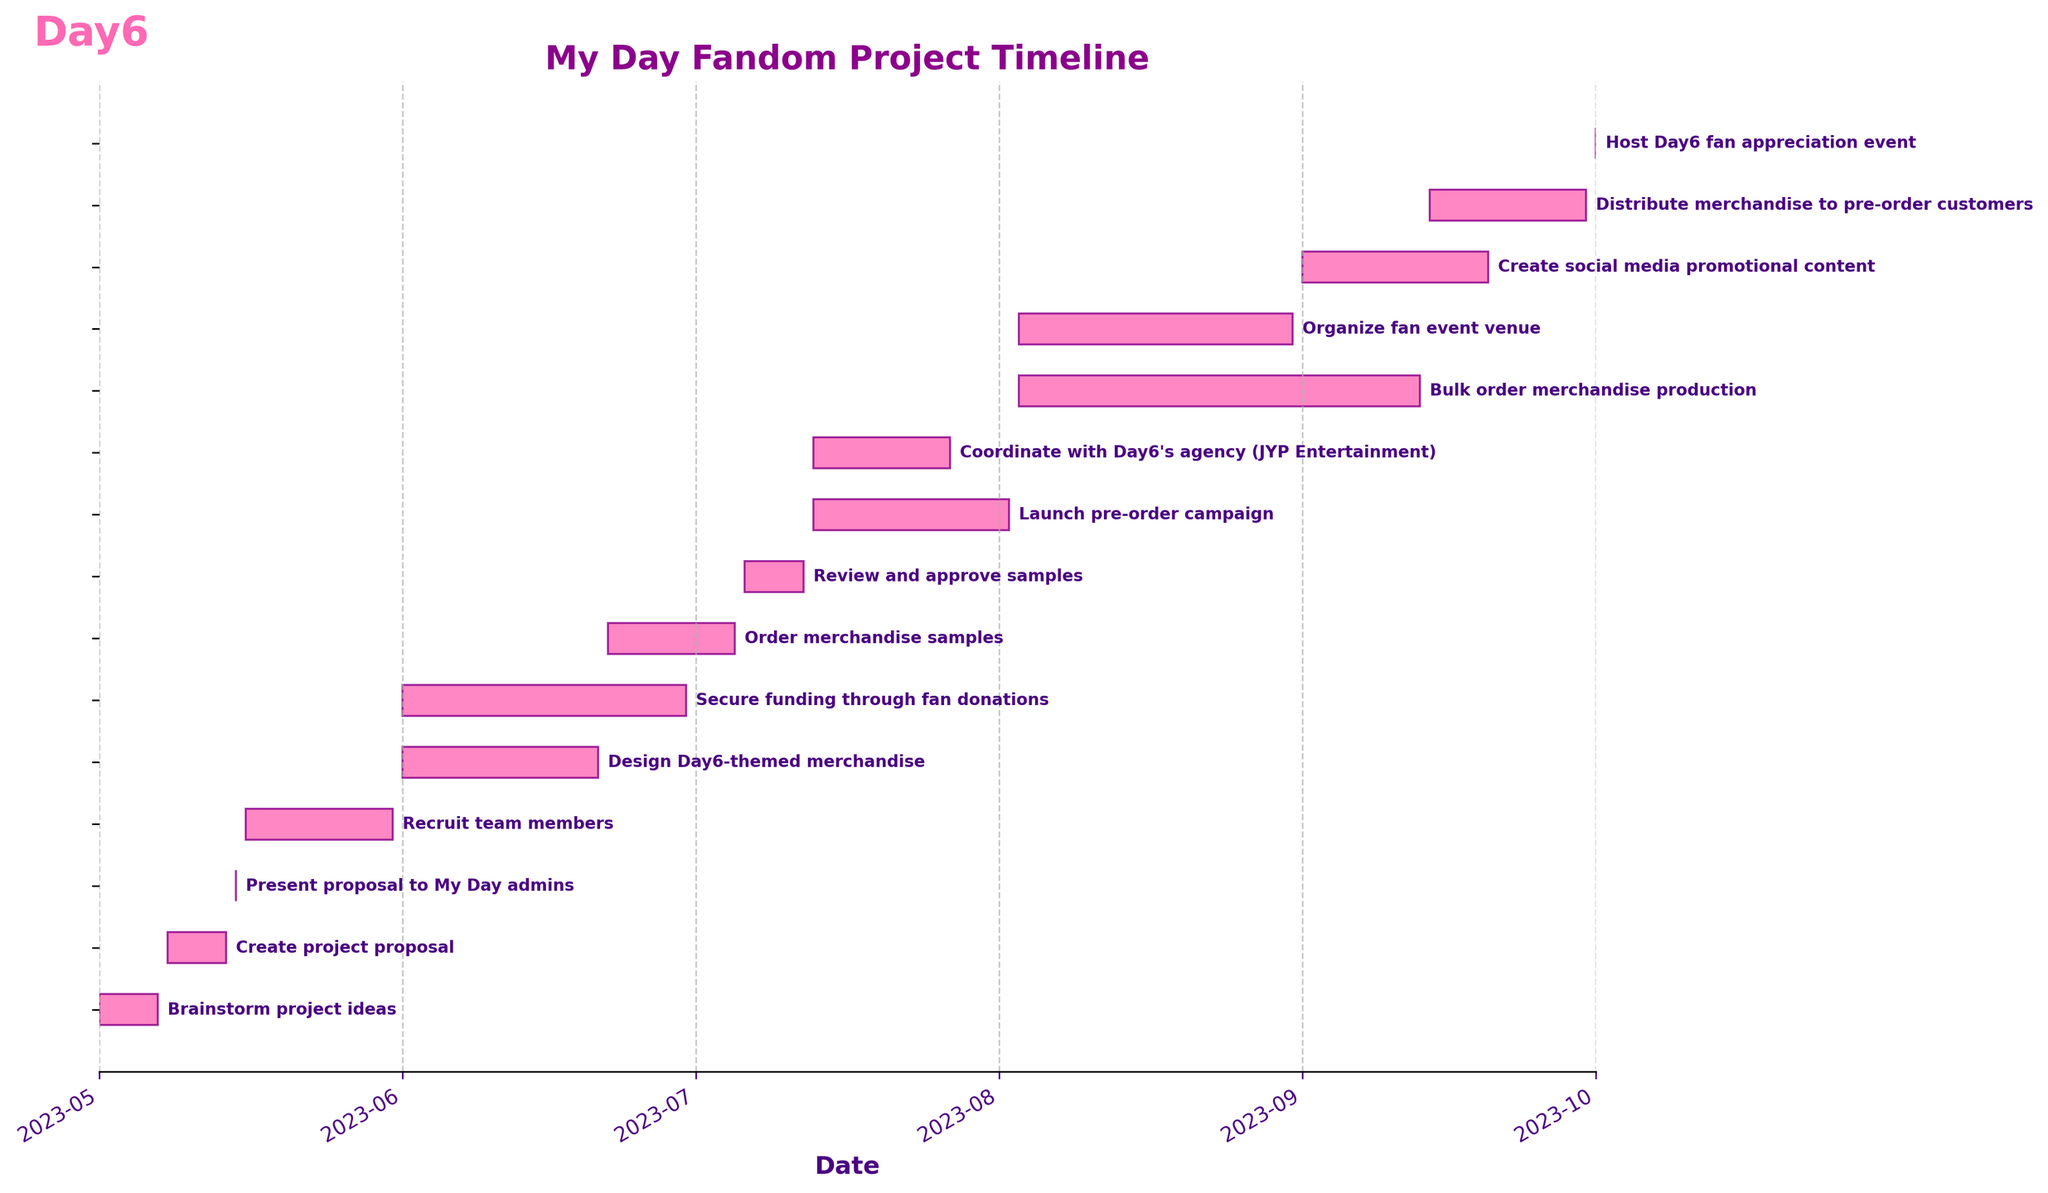What's the title of the figure? The title of the figure is typically placed at the top and is intended to give an overview of what the figure represents. In this case, the title is "My Day Fandom Project Timeline."
Answer: My Day Fandom Project Timeline How many tasks are there in total? By counting the number of horizontal bars or entries in the figure, you can determine the total number of tasks. Here, there are 15 tasks listed.
Answer: 15 What task starts and ends on the same day? By looking at the start and end dates on the timeline, the task that starts and ends on the same day can be identified. Here, the task "Present proposal to My Day admins" is scheduled for a single day.
Answer: Present proposal to My Day admins Which task takes the longest time to complete? To find the longest task, compare the lengths of the horizontal bars that represent the duration of each task. "Bulk order merchandise production" spans from 2023-08-03 to 2023-09-13, making it the longest task.
Answer: Bulk order merchandise production How many tasks are ongoing simultaneously on July 1st, 2023? Examine which tasks overlap on July 1st by checking the start and end dates. "Design Day6-themed merchandise" and "Secure funding through fan donations" are ongoing on this date.
Answer: 2 When does the pre-order campaign launch? To find the launch date of the pre-order campaign, look for the task "Launch pre-order campaign" and note its start date, which is July 13, 2023.
Answer: July 13, 2023 Which tasks overlap with "Order merchandise samples"? Check the tasks that have start and end dates intersecting with "Order merchandise samples," which runs from June 22 to July 5. "Secure funding through fan donations" runs within this period.
Answer: Secure funding through fan donations What's the total duration of the project from the first to the last task? Calculate the duration from the start date of the first task to the end date of the last task. The project starts on May 1, 2023, and ends on October 1, 2023, so the total duration is 154 days.
Answer: 154 days Which tasks require coordination with Day6's agency? Identify tasks that might involve external coordination. "Coordinate with Day6's agency (JYP Entertainment)" is explicitly related to this requirement.
Answer: Coordinate with Day6's agency (JYP Entertainment) Which task immediately follows the recruitment of team members? Look at the task timelines to see which task starts right after "Recruit team members" ends on May 31, 2023. The next task is "Design Day6-themed merchandise," which begins on June 1, 2023.
Answer: Design Day6-themed merchandise 